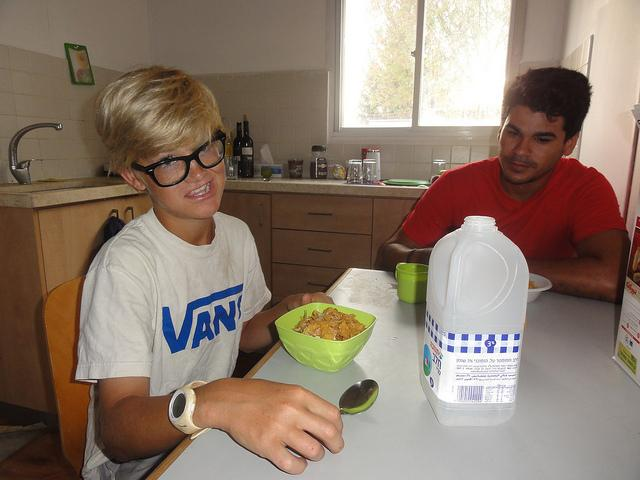What product does the young diner run out of here? Please explain your reasoning. milk. There is no milk left. 